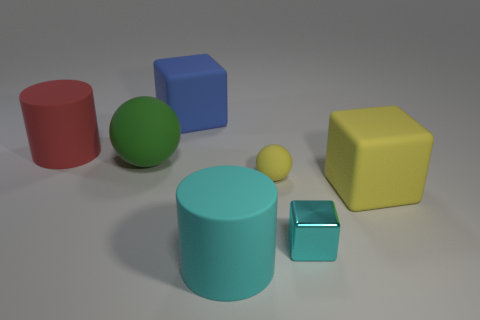Subtract all big yellow blocks. How many blocks are left? 2 Add 2 tiny cubes. How many objects exist? 9 Subtract all cubes. How many objects are left? 4 Subtract 0 brown cylinders. How many objects are left? 7 Subtract all blue cylinders. Subtract all large blue rubber things. How many objects are left? 6 Add 6 red cylinders. How many red cylinders are left? 7 Add 5 gray balls. How many gray balls exist? 5 